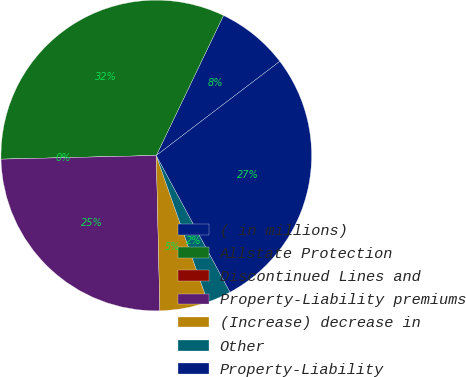Convert chart. <chart><loc_0><loc_0><loc_500><loc_500><pie_chart><fcel>( in millions)<fcel>Allstate Protection<fcel>Discontinued Lines and<fcel>Property-Liability premiums<fcel>(Increase) decrease in<fcel>Other<fcel>Property-Liability<nl><fcel>7.51%<fcel>32.5%<fcel>0.0%<fcel>24.99%<fcel>5.01%<fcel>2.5%<fcel>27.49%<nl></chart> 